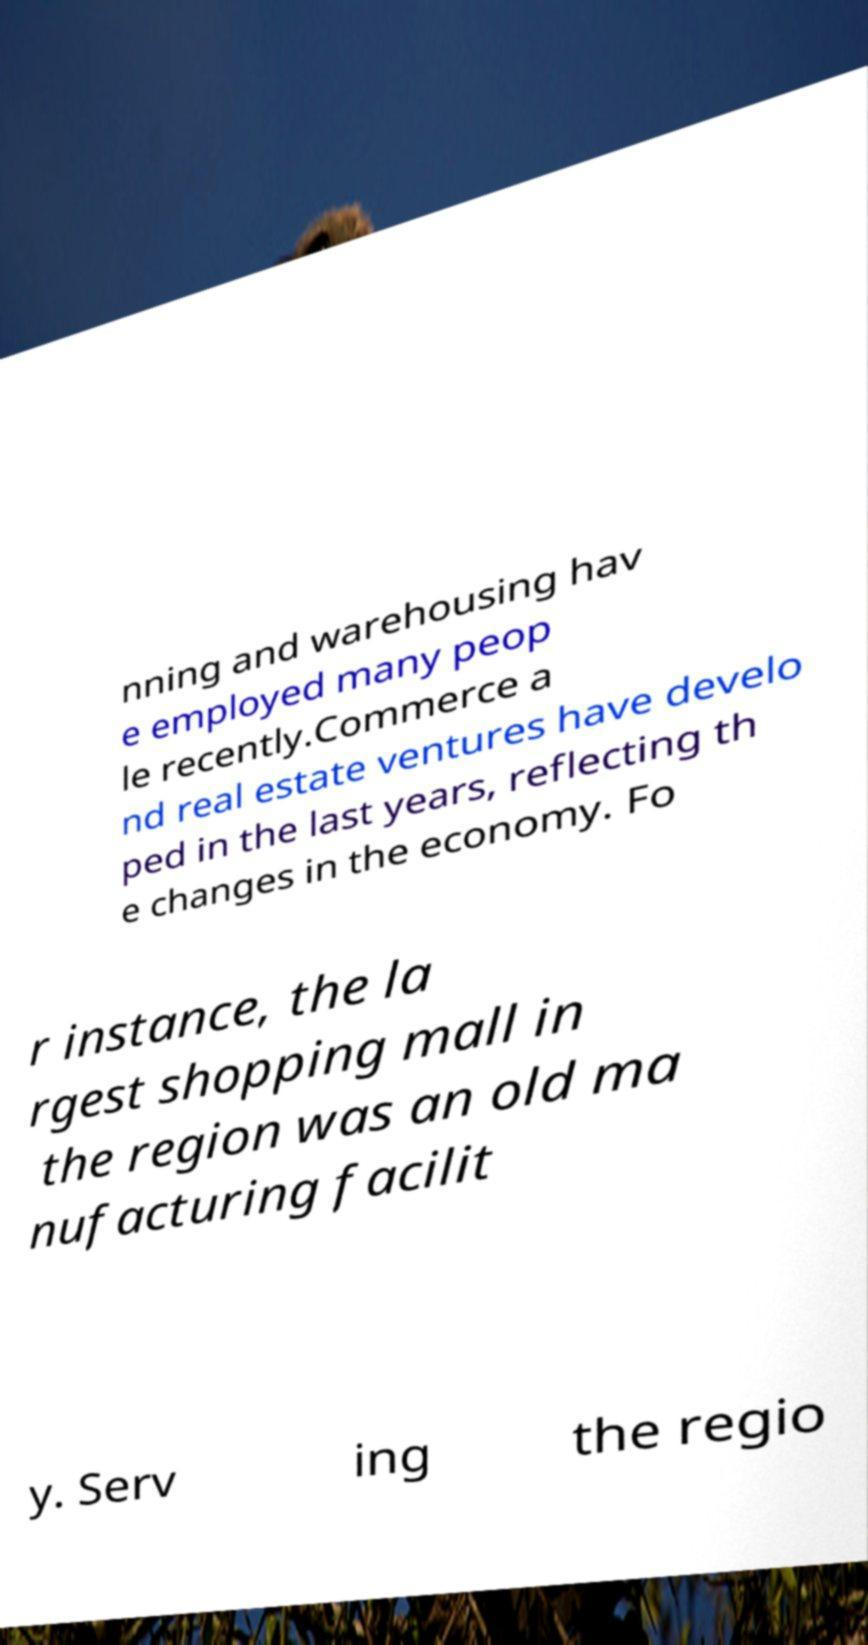Can you read and provide the text displayed in the image?This photo seems to have some interesting text. Can you extract and type it out for me? nning and warehousing hav e employed many peop le recently.Commerce a nd real estate ventures have develo ped in the last years, reflecting th e changes in the economy. Fo r instance, the la rgest shopping mall in the region was an old ma nufacturing facilit y. Serv ing the regio 